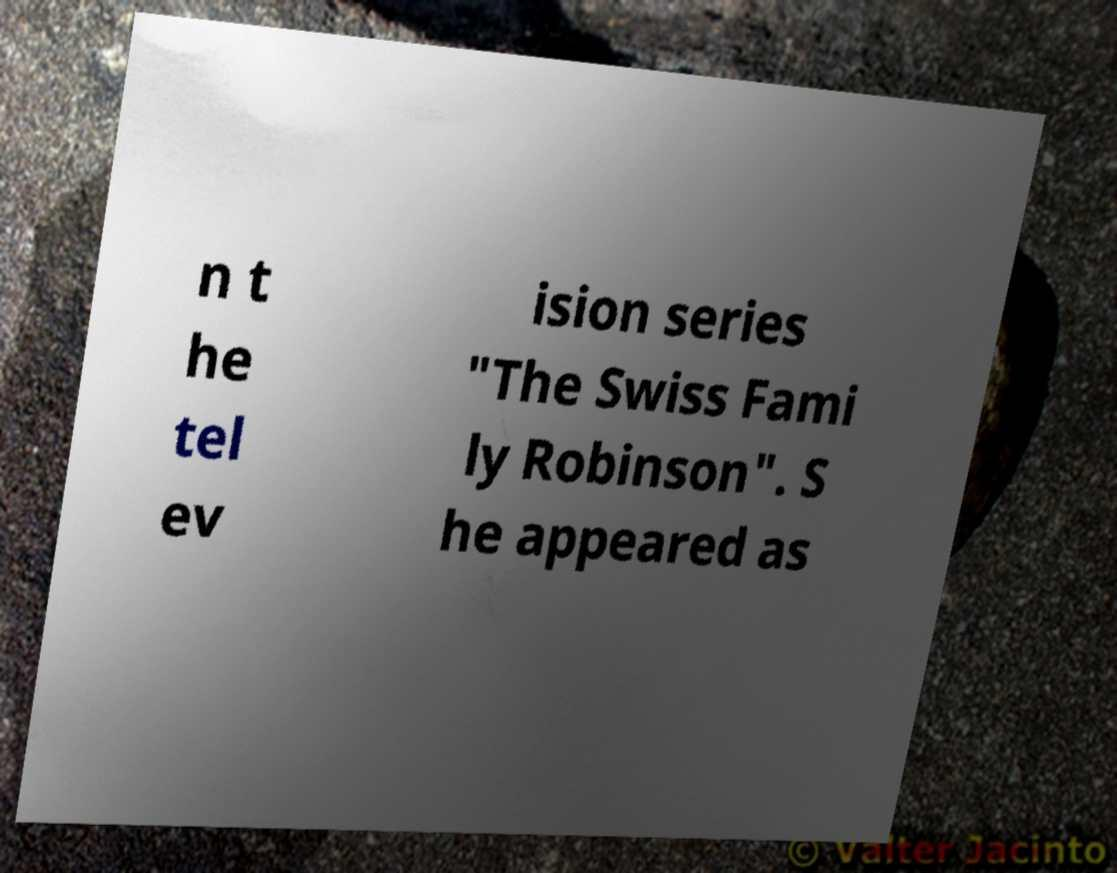Could you extract and type out the text from this image? n t he tel ev ision series "The Swiss Fami ly Robinson". S he appeared as 